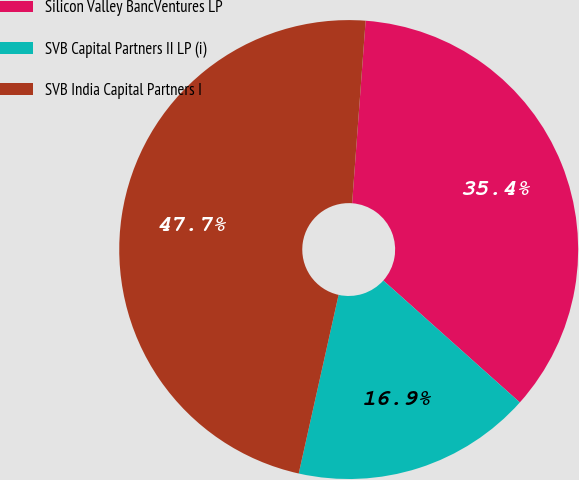Convert chart to OTSL. <chart><loc_0><loc_0><loc_500><loc_500><pie_chart><fcel>Silicon Valley BancVentures LP<fcel>SVB Capital Partners II LP (i)<fcel>SVB India Capital Partners I<nl><fcel>35.43%<fcel>16.89%<fcel>47.68%<nl></chart> 